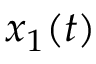Convert formula to latex. <formula><loc_0><loc_0><loc_500><loc_500>x _ { 1 } ( t )</formula> 